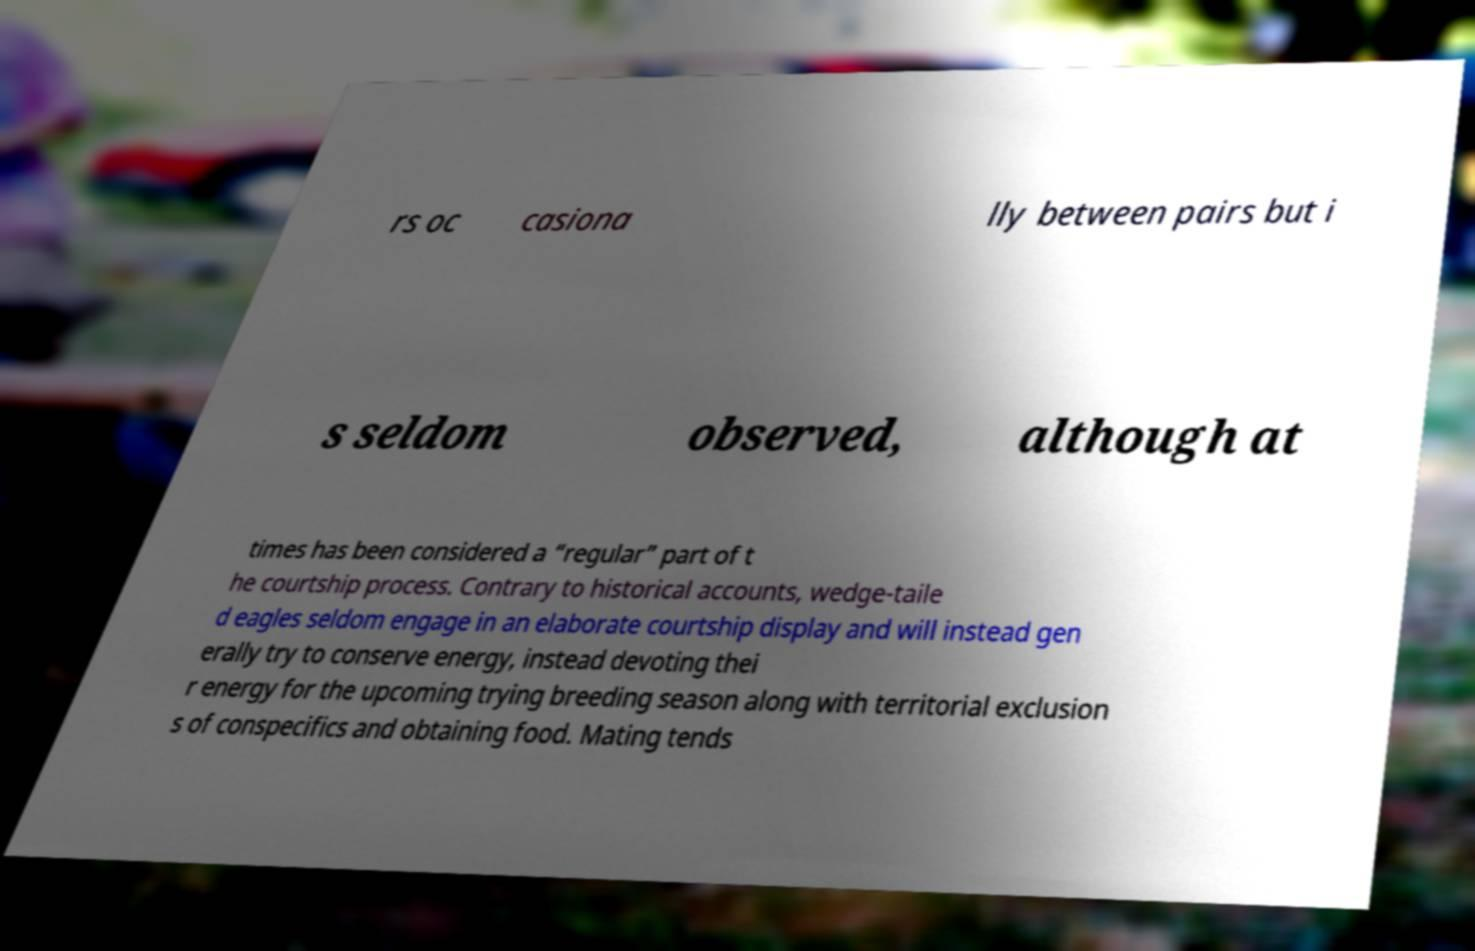Can you accurately transcribe the text from the provided image for me? rs oc casiona lly between pairs but i s seldom observed, although at times has been considered a “regular” part of t he courtship process. Contrary to historical accounts, wedge-taile d eagles seldom engage in an elaborate courtship display and will instead gen erally try to conserve energy, instead devoting thei r energy for the upcoming trying breeding season along with territorial exclusion s of conspecifics and obtaining food. Mating tends 